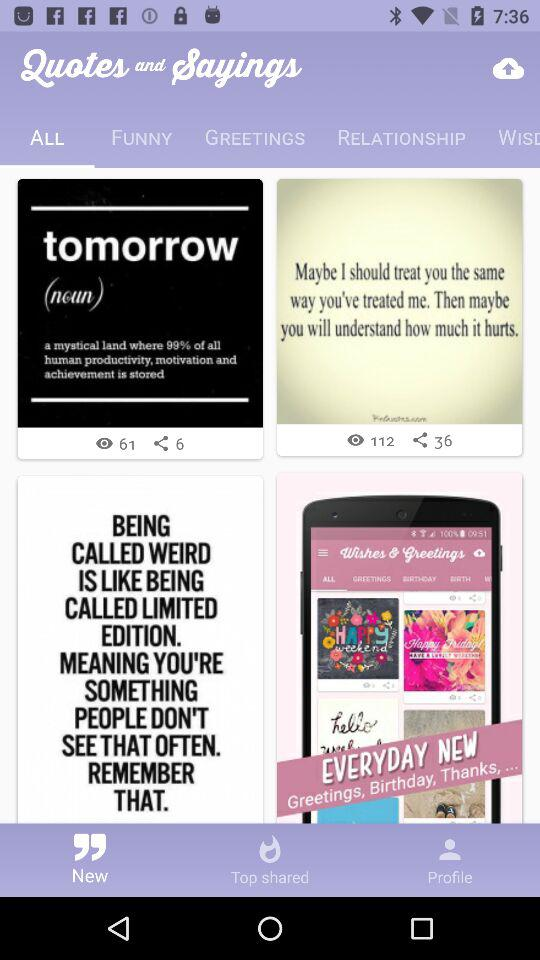How many funny quotes and sayings are available?
When the provided information is insufficient, respond with <no answer>. <no answer> 